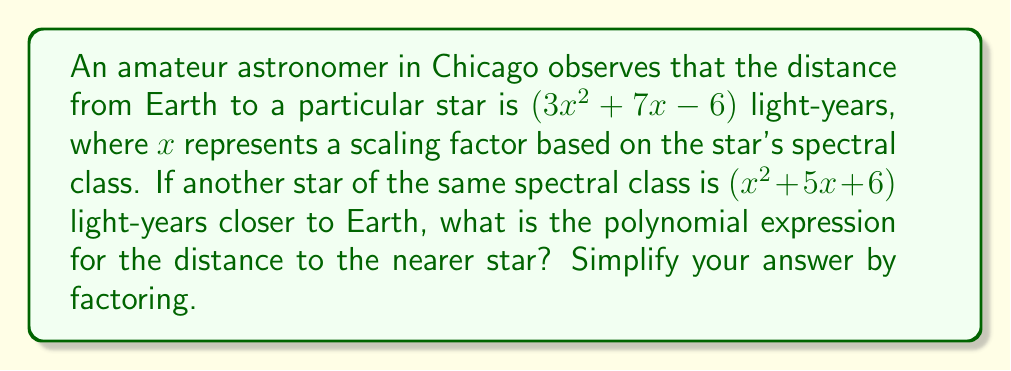Can you solve this math problem? Let's approach this step-by-step:

1) The distance to the first star is $(3x^2 + 7x - 6)$ light-years.

2) The second star is $(x^2 + 5x + 6)$ light-years closer to Earth.

3) To find the distance to the nearer star, we need to subtract the difference from the original distance:

   $$(3x^2 + 7x - 6) - (x^2 + 5x + 6)$$

4) Let's subtract these polynomials:
   
   $3x^2 + 7x - 6$
   $-(x^2 + 5x + 6)$
   $----------------$
   $2x^2 + 2x - 12$

5) Now we need to factor this result. Let's use the ac-method:

   a) $a = 2$, $b = 2$, $c = -12$
   b) We need to find two numbers that multiply to give $ac = 2 * -12 = -24$ and add to give $b = 2$
   c) These numbers are 6 and -4

6) Rewrite the middle term:

   $2x^2 + 6x - 4x - 12$

7) Factor by grouping:

   $2x(x + 3) - 4(x + 3)$
   $(2x - 4)(x + 3)$
   $2(x - 2)(x + 3)$

This is the fully factored form of the polynomial representing the distance to the nearer star.
Answer: $2(x - 2)(x + 3)$ light-years 